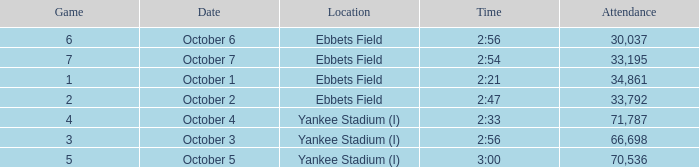Yankee stadium (i), and a time of 3:00 has what attendance for this location? 70536.0. 